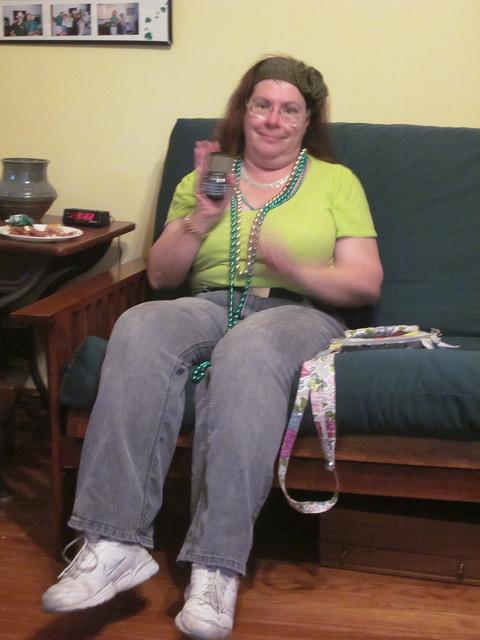What is around the woman's neck?
Write a very short answer. Beads. Are there any dogs?
Write a very short answer. No. What is on the plate?
Keep it brief. Food. What is the lady doing?
Write a very short answer. Sitting. How many necklaces is the woman wearing?
Write a very short answer. 3. Where is the woman sitting?
Concise answer only. Couch. What is the pink and purple toy that's pictured?
Keep it brief. 0. What color is the woman's shirt?
Write a very short answer. Green. 